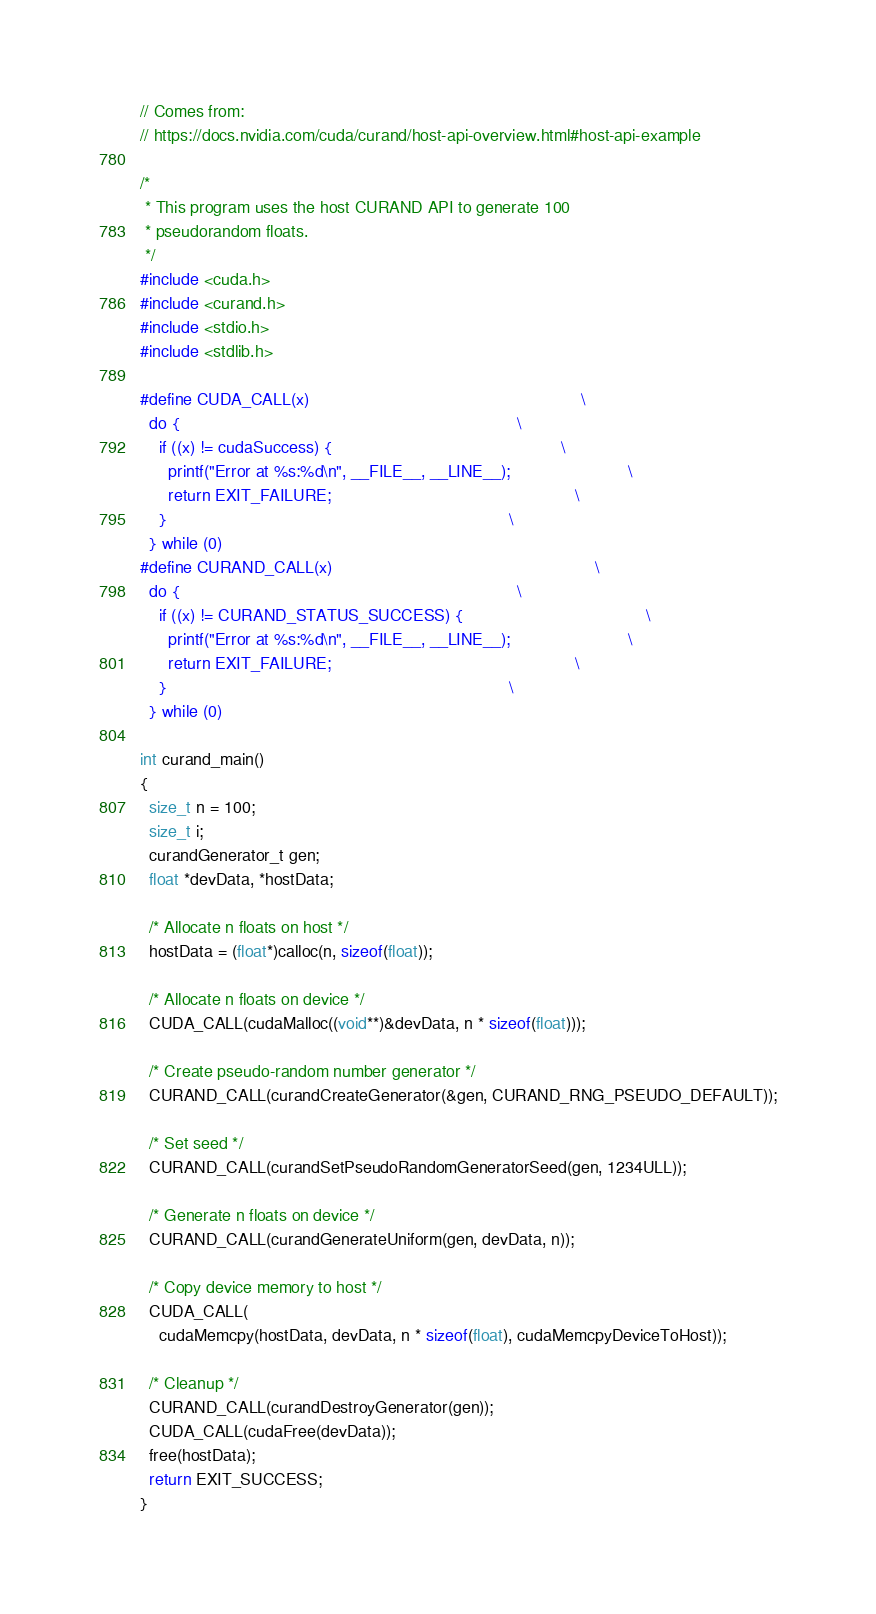Convert code to text. <code><loc_0><loc_0><loc_500><loc_500><_Cuda_>// Comes from:
// https://docs.nvidia.com/cuda/curand/host-api-overview.html#host-api-example

/*
 * This program uses the host CURAND API to generate 100
 * pseudorandom floats.
 */
#include <cuda.h>
#include <curand.h>
#include <stdio.h>
#include <stdlib.h>

#define CUDA_CALL(x)                                                          \
  do {                                                                        \
    if ((x) != cudaSuccess) {                                                 \
      printf("Error at %s:%d\n", __FILE__, __LINE__);                         \
      return EXIT_FAILURE;                                                    \
    }                                                                         \
  } while (0)
#define CURAND_CALL(x)                                                        \
  do {                                                                        \
    if ((x) != CURAND_STATUS_SUCCESS) {                                       \
      printf("Error at %s:%d\n", __FILE__, __LINE__);                         \
      return EXIT_FAILURE;                                                    \
    }                                                                         \
  } while (0)

int curand_main()
{
  size_t n = 100;
  size_t i;
  curandGenerator_t gen;
  float *devData, *hostData;

  /* Allocate n floats on host */
  hostData = (float*)calloc(n, sizeof(float));

  /* Allocate n floats on device */
  CUDA_CALL(cudaMalloc((void**)&devData, n * sizeof(float)));

  /* Create pseudo-random number generator */
  CURAND_CALL(curandCreateGenerator(&gen, CURAND_RNG_PSEUDO_DEFAULT));

  /* Set seed */
  CURAND_CALL(curandSetPseudoRandomGeneratorSeed(gen, 1234ULL));

  /* Generate n floats on device */
  CURAND_CALL(curandGenerateUniform(gen, devData, n));

  /* Copy device memory to host */
  CUDA_CALL(
    cudaMemcpy(hostData, devData, n * sizeof(float), cudaMemcpyDeviceToHost));

  /* Cleanup */
  CURAND_CALL(curandDestroyGenerator(gen));
  CUDA_CALL(cudaFree(devData));
  free(hostData);
  return EXIT_SUCCESS;
}
</code> 